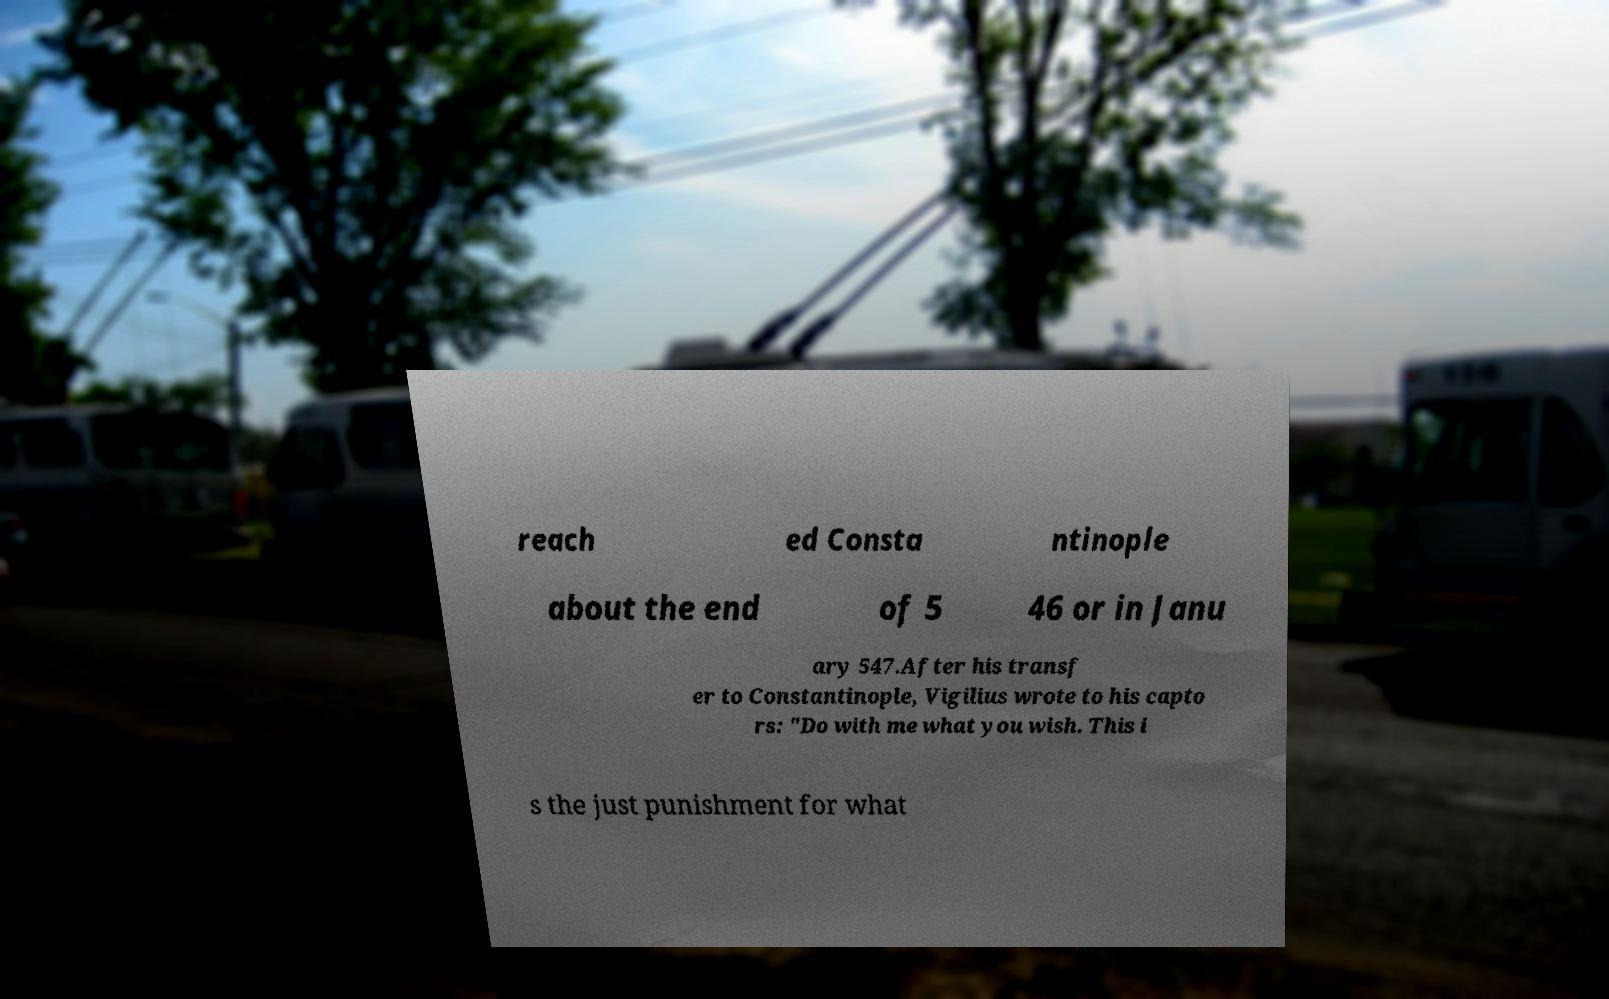Could you assist in decoding the text presented in this image and type it out clearly? reach ed Consta ntinople about the end of 5 46 or in Janu ary 547.After his transf er to Constantinople, Vigilius wrote to his capto rs: "Do with me what you wish. This i s the just punishment for what 